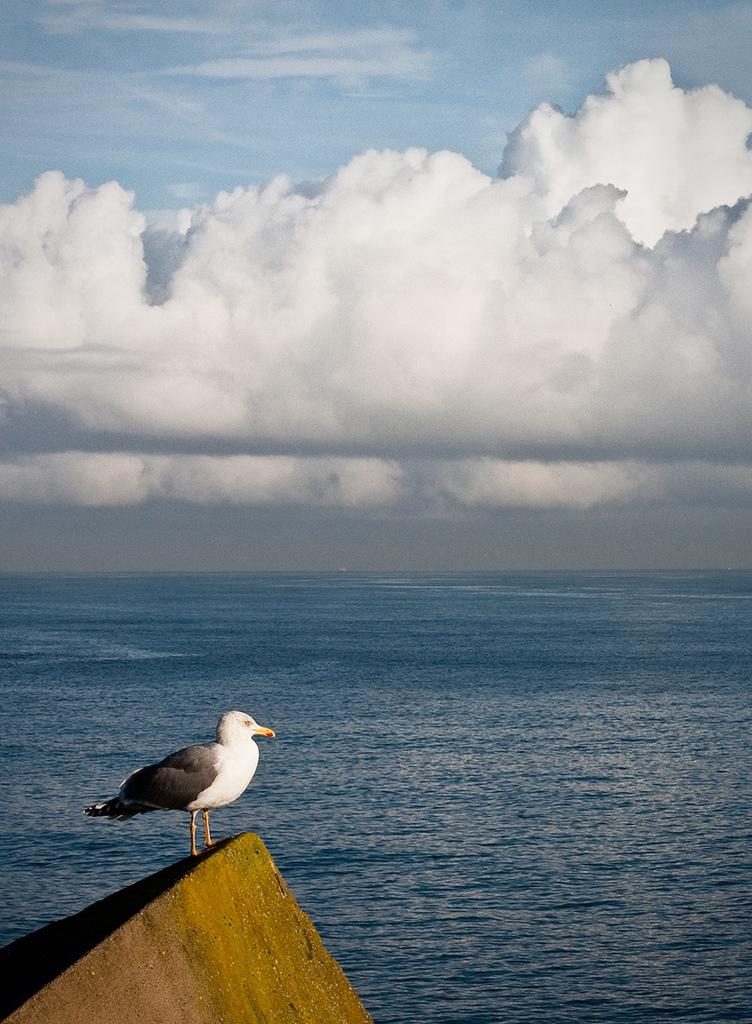What type of animal can be seen in the image? There is a bird in the image. What is the bird perched on? The bird is on an object in the image. What natural element is visible in the image? Water is visible in the image. What can be seen in the background of the image? The sky is visible in the background of the image. What are the clouds doing in the sky? Clouds are present in the sky. What type of sticks are being used to create trouble for the bird in the image? There are no sticks or any indication of trouble for the bird in the image. 